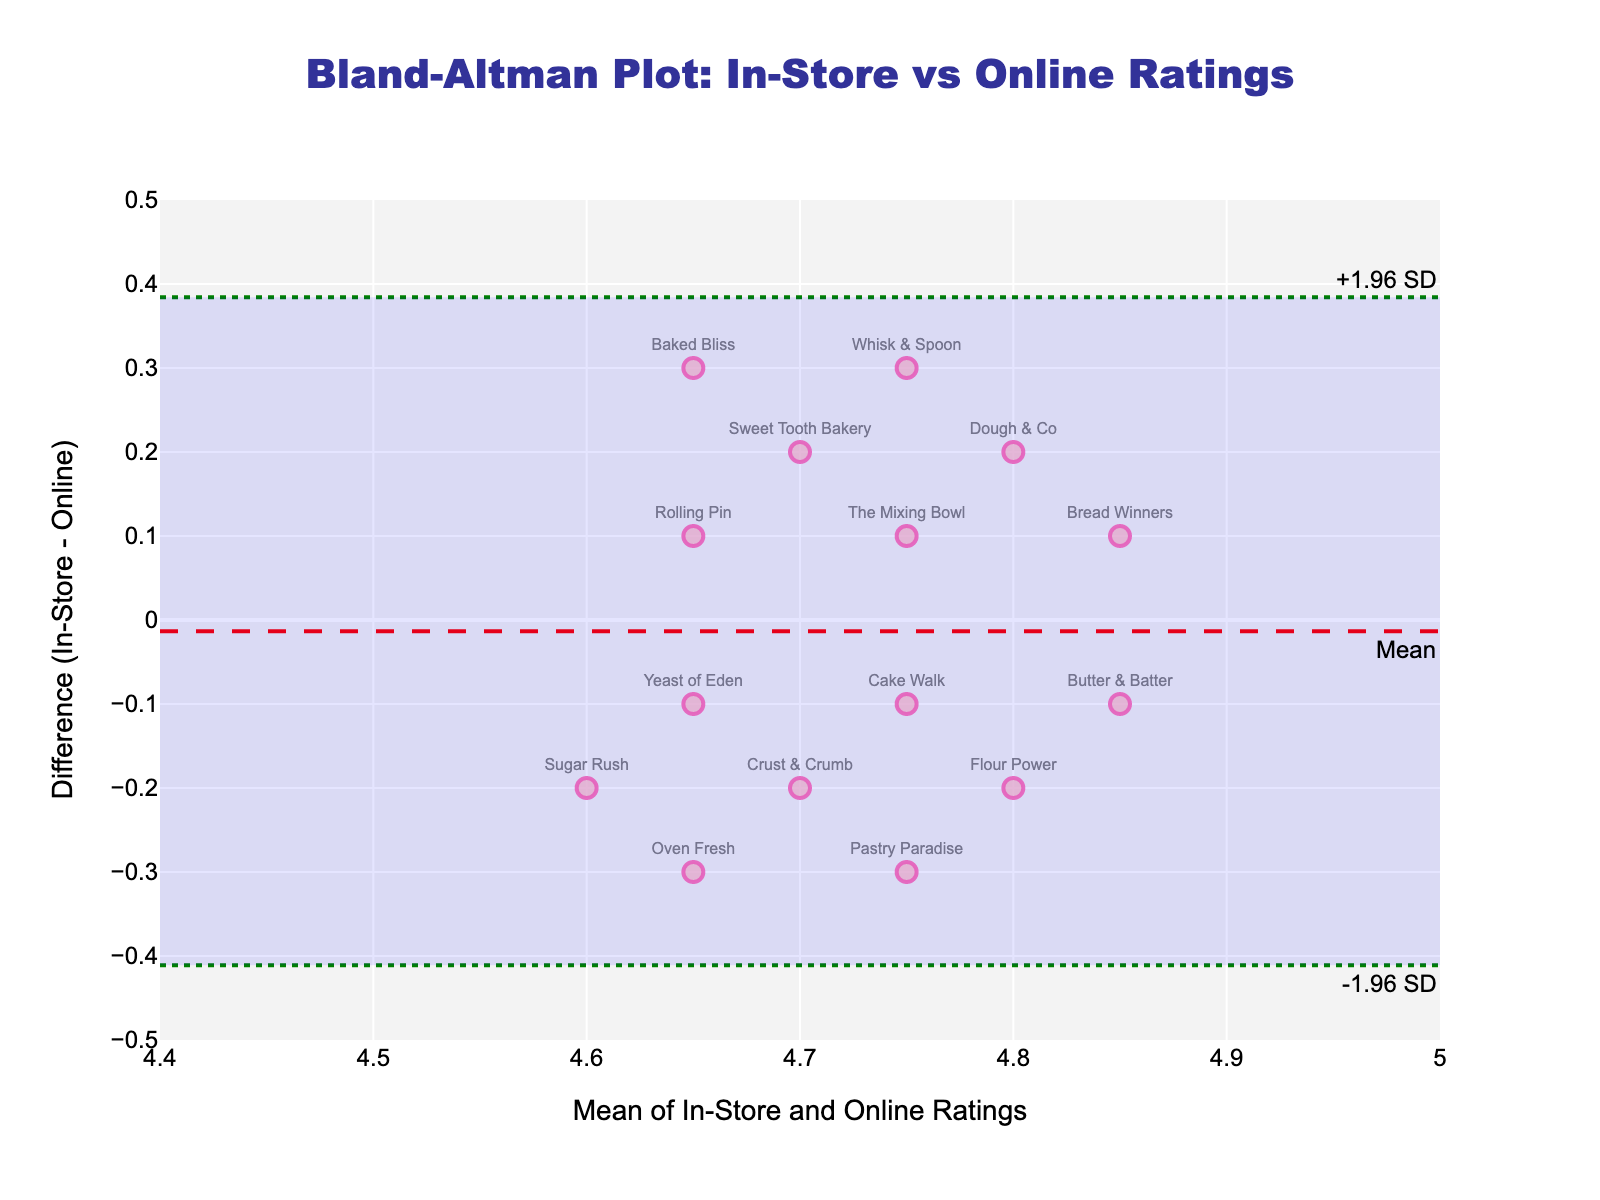What is the title of the plot? The title of the plot is displayed at the top center of the graph, reading "Bland-Altman Plot: In-Store vs Online Ratings".
Answer: Bland-Altman Plot: In-Store vs Online Ratings How many data points are shown in the plot? Counting the markers (points) on the plot, there are 15 data points present.
Answer: 15 What are the x-axis and y-axis titles? The x-axis and y-axis titles are located below and to the left of the plot, respectively. The x-axis title is "Mean of In-Store and Online Ratings" and the y-axis title is "Difference (In-Store - Online)".
Answer: Mean of In-Store and Online Ratings; Difference (In-Store - Online) What is the mean difference shown in the plot? The mean difference is indicated by the dashed red line labeled "Mean" on the y-axis, which corresponds to a y-value. By referencing this line, we determine the mean difference.
Answer: 0 Which bakery has the highest mean rating? By looking at the x-axis and finding the point farthest to the right, we identify "Butter & Batter" as having the highest mean rating. This can be confirmed as it corresponds to the highest x value.
Answer: Butter & Batter What are the upper and lower limits of agreement? The upper and lower limits are represented by the dotted green lines labeled "+1.96 SD" and "-1.96 SD" respectively. These lines indicate the range for the limits of agreement on the y-axis.
Answer: +0.36 and -0.36 Which bakery has the largest positive difference between in-store and online ratings? By finding the data point with the highest y-value (difference) on the plot, "Whisk & Spoon" has the largest positive difference between the in-store and online ratings.
Answer: Whisk & Spoon How many bakeries have a difference in their in-store and online ratings within the limits of agreement? Within the highlighted blue rectangular area (which represents the limits of agreement), count the number of data points falling within this region. We can see that a majority of bakeries fall within this range, which sums up to 13.
Answer: 13 What does the area between the dotted green lines indicate? The area between the dotted green lines (limits of agreement) indicates where most of the differences between in-store and online ratings fall. This area signifies the range within which the differences are considered to be statistically acceptable.
Answer: Limits of agreement Are there any bakeries with a negative difference in ratings? By examining the plot, observe the data points that fall below the y=0 line, indicating a negative difference between in-store and online ratings. Yes, there are bakeries like "Baked Bliss" with a negative difference.
Answer: Yes, there are 